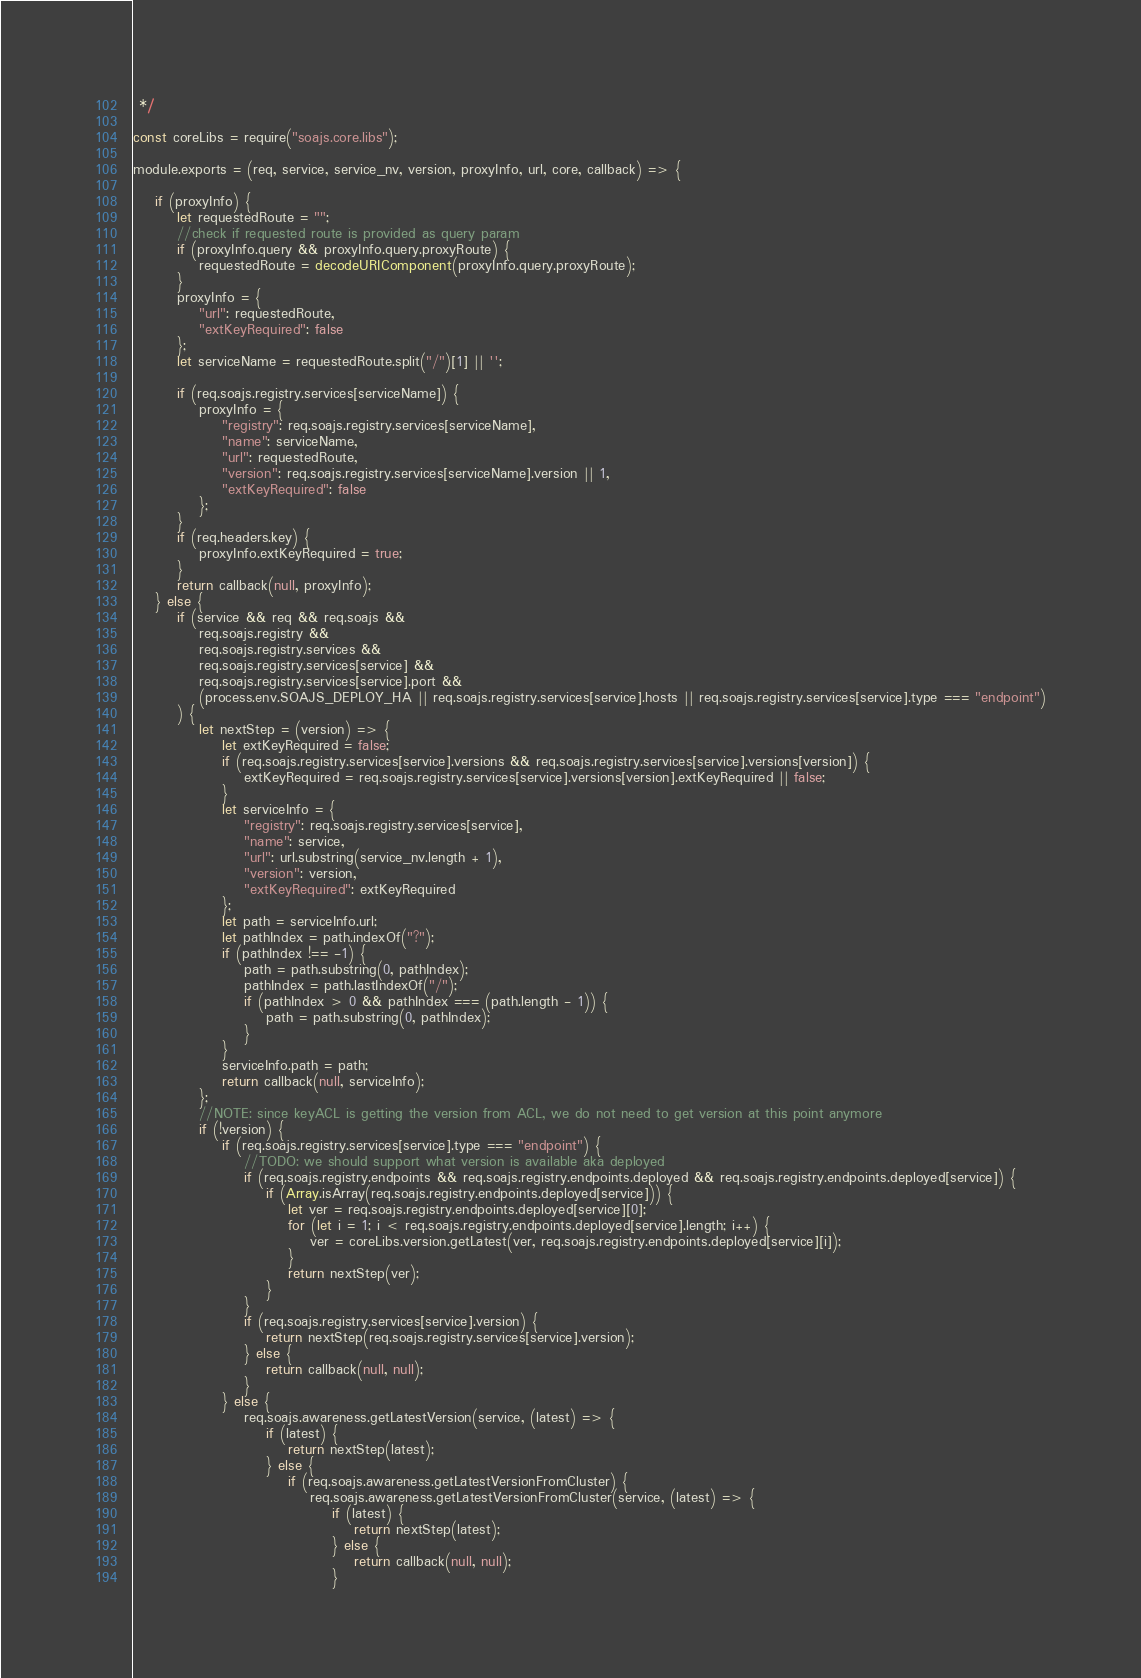<code> <loc_0><loc_0><loc_500><loc_500><_JavaScript_> */

const coreLibs = require("soajs.core.libs");

module.exports = (req, service, service_nv, version, proxyInfo, url, core, callback) => {
	
	if (proxyInfo) {
		let requestedRoute = "";
		//check if requested route is provided as query param
		if (proxyInfo.query && proxyInfo.query.proxyRoute) {
			requestedRoute = decodeURIComponent(proxyInfo.query.proxyRoute);
		}
		proxyInfo = {
			"url": requestedRoute,
			"extKeyRequired": false
		};
		let serviceName = requestedRoute.split("/")[1] || '';
		
		if (req.soajs.registry.services[serviceName]) {
			proxyInfo = {
				"registry": req.soajs.registry.services[serviceName],
				"name": serviceName,
				"url": requestedRoute,
				"version": req.soajs.registry.services[serviceName].version || 1,
				"extKeyRequired": false
			};
		}
		if (req.headers.key) {
			proxyInfo.extKeyRequired = true;
		}
		return callback(null, proxyInfo);
	} else {
		if (service && req && req.soajs &&
			req.soajs.registry &&
			req.soajs.registry.services &&
			req.soajs.registry.services[service] &&
			req.soajs.registry.services[service].port &&
			(process.env.SOAJS_DEPLOY_HA || req.soajs.registry.services[service].hosts || req.soajs.registry.services[service].type === "endpoint")
		) {
			let nextStep = (version) => {
				let extKeyRequired = false;
				if (req.soajs.registry.services[service].versions && req.soajs.registry.services[service].versions[version]) {
					extKeyRequired = req.soajs.registry.services[service].versions[version].extKeyRequired || false;
				}
				let serviceInfo = {
					"registry": req.soajs.registry.services[service],
					"name": service,
					"url": url.substring(service_nv.length + 1),
					"version": version,
					"extKeyRequired": extKeyRequired
				};
				let path = serviceInfo.url;
				let pathIndex = path.indexOf("?");
				if (pathIndex !== -1) {
					path = path.substring(0, pathIndex);
					pathIndex = path.lastIndexOf("/");
					if (pathIndex > 0 && pathIndex === (path.length - 1)) {
						path = path.substring(0, pathIndex);
					}
				}
				serviceInfo.path = path;
				return callback(null, serviceInfo);
			};
			//NOTE: since keyACL is getting the version from ACL, we do not need to get version at this point anymore
			if (!version) {
				if (req.soajs.registry.services[service].type === "endpoint") {
					//TODO: we should support what version is available aka deployed
					if (req.soajs.registry.endpoints && req.soajs.registry.endpoints.deployed && req.soajs.registry.endpoints.deployed[service]) {
						if (Array.isArray(req.soajs.registry.endpoints.deployed[service])) {
							let ver = req.soajs.registry.endpoints.deployed[service][0];
							for (let i = 1; i < req.soajs.registry.endpoints.deployed[service].length; i++) {
								ver = coreLibs.version.getLatest(ver, req.soajs.registry.endpoints.deployed[service][i]);
							}
							return nextStep(ver);
						}
					}
					if (req.soajs.registry.services[service].version) {
						return nextStep(req.soajs.registry.services[service].version);
					} else {
						return callback(null, null);
					}
				} else {
					req.soajs.awareness.getLatestVersion(service, (latest) => {
						if (latest) {
							return nextStep(latest);
						} else {
							if (req.soajs.awareness.getLatestVersionFromCluster) {
								req.soajs.awareness.getLatestVersionFromCluster(service, (latest) => {
									if (latest) {
										return nextStep(latest);
									} else {
										return callback(null, null);
									}</code> 